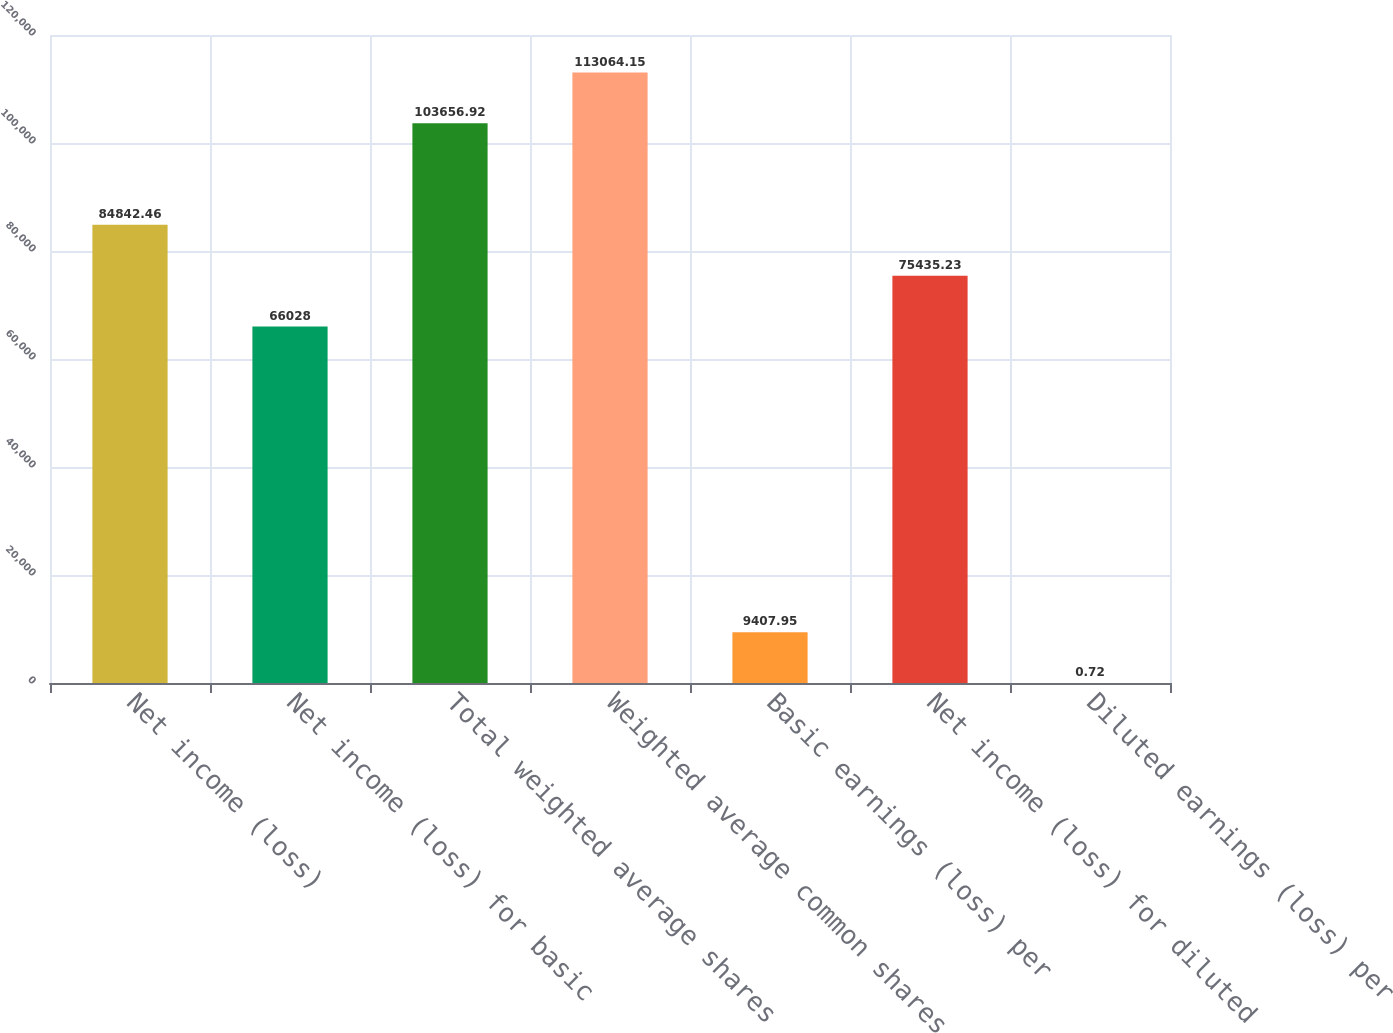Convert chart. <chart><loc_0><loc_0><loc_500><loc_500><bar_chart><fcel>Net income (loss)<fcel>Net income (loss) for basic<fcel>Total weighted average shares<fcel>Weighted average common shares<fcel>Basic earnings (loss) per<fcel>Net income (loss) for diluted<fcel>Diluted earnings (loss) per<nl><fcel>84842.5<fcel>66028<fcel>103657<fcel>113064<fcel>9407.95<fcel>75435.2<fcel>0.72<nl></chart> 